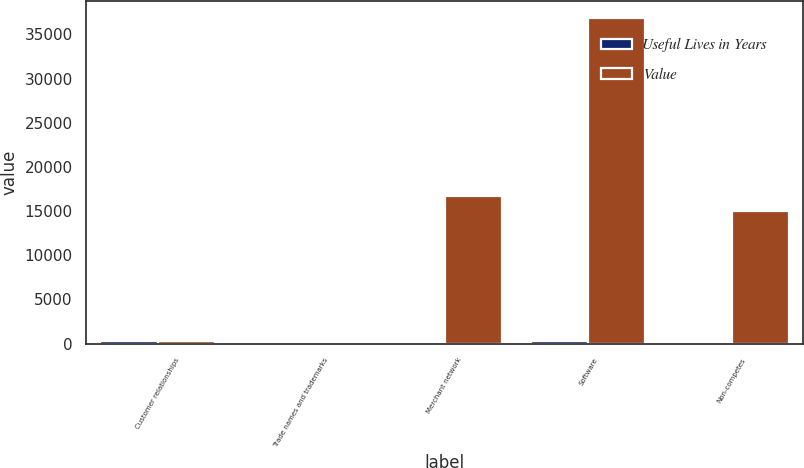Convert chart. <chart><loc_0><loc_0><loc_500><loc_500><stacked_bar_chart><ecel><fcel>Customer relationships<fcel>Trade names and trademarks<fcel>Merchant network<fcel>Software<fcel>Non-competes<nl><fcel>Useful Lives in Years<fcel>320<fcel>15<fcel>10<fcel>310<fcel>5<nl><fcel>Value<fcel>310<fcel>200<fcel>16750<fcel>36890<fcel>15000<nl></chart> 